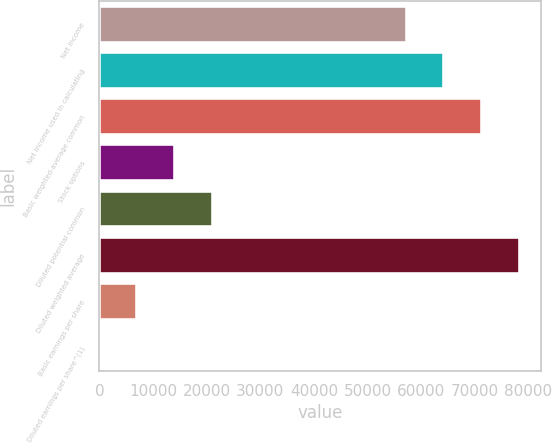Convert chart to OTSL. <chart><loc_0><loc_0><loc_500><loc_500><bar_chart><fcel>Net income<fcel>Net income used in calculating<fcel>Basic weighted-average common<fcel>Stock options<fcel>Diluted potential common<fcel>Diluted weighted average<fcel>Basic earnings per share<fcel>Diluted earnings per share^(1)<nl><fcel>57284<fcel>64309<fcel>71334<fcel>14050.9<fcel>21075.9<fcel>78359.1<fcel>7025.84<fcel>0.82<nl></chart> 